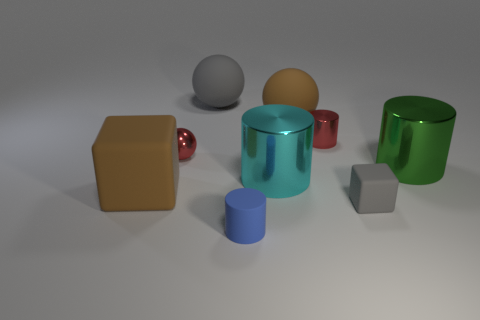Subtract 1 cylinders. How many cylinders are left? 3 Add 1 purple blocks. How many objects exist? 10 Subtract all balls. How many objects are left? 6 Subtract all shiny cylinders. Subtract all large cyan cylinders. How many objects are left? 5 Add 8 tiny metallic cylinders. How many tiny metallic cylinders are left? 9 Add 7 big balls. How many big balls exist? 9 Subtract 0 red blocks. How many objects are left? 9 